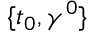Convert formula to latex. <formula><loc_0><loc_0><loc_500><loc_500>\{ t _ { 0 } , { \gamma } ^ { 0 } \}</formula> 